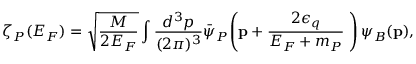<formula> <loc_0><loc_0><loc_500><loc_500>\zeta _ { P } ( E _ { F } ) = \sqrt { \frac { M } { 2 E _ { F } } } \int \frac { d ^ { 3 } p } { ( 2 \pi ) ^ { 3 } } \bar { \psi } _ { P } \, \left ( { p } + \frac { 2 \epsilon _ { q } } { E _ { F } + m _ { P } } { \Delta } \right ) \psi _ { B } ( { p } ) ,</formula> 